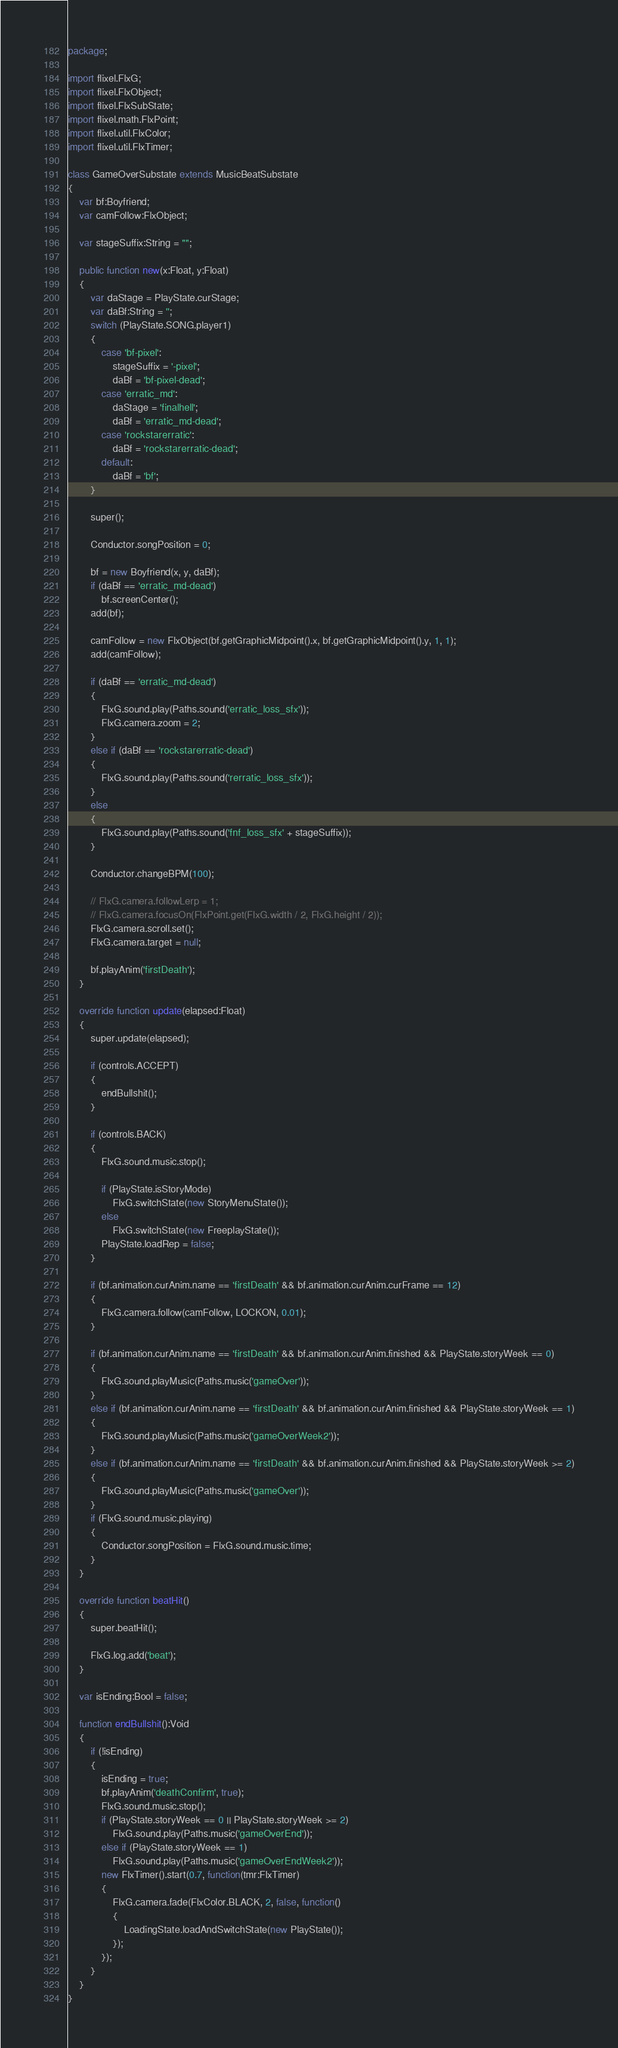<code> <loc_0><loc_0><loc_500><loc_500><_Haxe_>package;

import flixel.FlxG;
import flixel.FlxObject;
import flixel.FlxSubState;
import flixel.math.FlxPoint;
import flixel.util.FlxColor;
import flixel.util.FlxTimer;

class GameOverSubstate extends MusicBeatSubstate
{
	var bf:Boyfriend;
	var camFollow:FlxObject;

	var stageSuffix:String = "";

	public function new(x:Float, y:Float)
	{
		var daStage = PlayState.curStage;
		var daBf:String = '';
		switch (PlayState.SONG.player1)
		{
			case 'bf-pixel':
				stageSuffix = '-pixel';
				daBf = 'bf-pixel-dead';
			case 'erratic_md':
				daStage = 'finalhell';
				daBf = 'erratic_md-dead';
			case 'rockstarerratic':
				daBf = 'rockstarerratic-dead';
			default:
				daBf = 'bf';
		}

		super();

		Conductor.songPosition = 0;

		bf = new Boyfriend(x, y, daBf);
		if (daBf == 'erratic_md-dead')
			bf.screenCenter();
		add(bf);

		camFollow = new FlxObject(bf.getGraphicMidpoint().x, bf.getGraphicMidpoint().y, 1, 1);
		add(camFollow);

		if (daBf == 'erratic_md-dead')
		{
			FlxG.sound.play(Paths.sound('erratic_loss_sfx'));
			FlxG.camera.zoom = 2;
		}
		else if (daBf == 'rockstarerratic-dead')
		{
			FlxG.sound.play(Paths.sound('rerratic_loss_sfx'));
		}
		else
		{
			FlxG.sound.play(Paths.sound('fnf_loss_sfx' + stageSuffix));
		}

		Conductor.changeBPM(100);

		// FlxG.camera.followLerp = 1;
		// FlxG.camera.focusOn(FlxPoint.get(FlxG.width / 2, FlxG.height / 2));
		FlxG.camera.scroll.set();
		FlxG.camera.target = null;

		bf.playAnim('firstDeath');
	}

	override function update(elapsed:Float)
	{
		super.update(elapsed);

		if (controls.ACCEPT)
		{
			endBullshit();
		}

		if (controls.BACK)
		{
			FlxG.sound.music.stop();

			if (PlayState.isStoryMode)
				FlxG.switchState(new StoryMenuState());
			else
				FlxG.switchState(new FreeplayState());
			PlayState.loadRep = false;
		}

		if (bf.animation.curAnim.name == 'firstDeath' && bf.animation.curAnim.curFrame == 12)
		{
			FlxG.camera.follow(camFollow, LOCKON, 0.01);
		}

		if (bf.animation.curAnim.name == 'firstDeath' && bf.animation.curAnim.finished && PlayState.storyWeek == 0)
		{
			FlxG.sound.playMusic(Paths.music('gameOver'));
		}
		else if (bf.animation.curAnim.name == 'firstDeath' && bf.animation.curAnim.finished && PlayState.storyWeek == 1)
		{
			FlxG.sound.playMusic(Paths.music('gameOverWeek2'));
		}
		else if (bf.animation.curAnim.name == 'firstDeath' && bf.animation.curAnim.finished && PlayState.storyWeek >= 2)
		{
			FlxG.sound.playMusic(Paths.music('gameOver'));
		}
		if (FlxG.sound.music.playing)
		{
			Conductor.songPosition = FlxG.sound.music.time;
		}
	}

	override function beatHit()
	{
		super.beatHit();

		FlxG.log.add('beat');
	}

	var isEnding:Bool = false;

	function endBullshit():Void
	{
		if (!isEnding)
		{
			isEnding = true;
			bf.playAnim('deathConfirm', true);
			FlxG.sound.music.stop();
			if (PlayState.storyWeek == 0 || PlayState.storyWeek >= 2)
				FlxG.sound.play(Paths.music('gameOverEnd'));
			else if (PlayState.storyWeek == 1)
				FlxG.sound.play(Paths.music('gameOverEndWeek2'));
			new FlxTimer().start(0.7, function(tmr:FlxTimer)
			{
				FlxG.camera.fade(FlxColor.BLACK, 2, false, function()
				{
					LoadingState.loadAndSwitchState(new PlayState());
				});
			});
		}
	}
}
</code> 